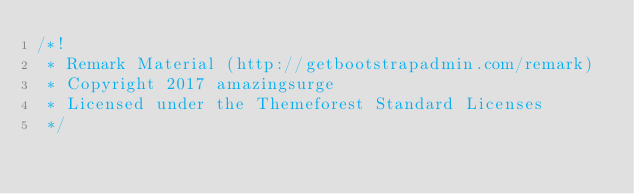<code> <loc_0><loc_0><loc_500><loc_500><_CSS_>/*!
 * Remark Material (http://getbootstrapadmin.com/remark)
 * Copyright 2017 amazingsurge
 * Licensed under the Themeforest Standard Licenses
 */
</code> 